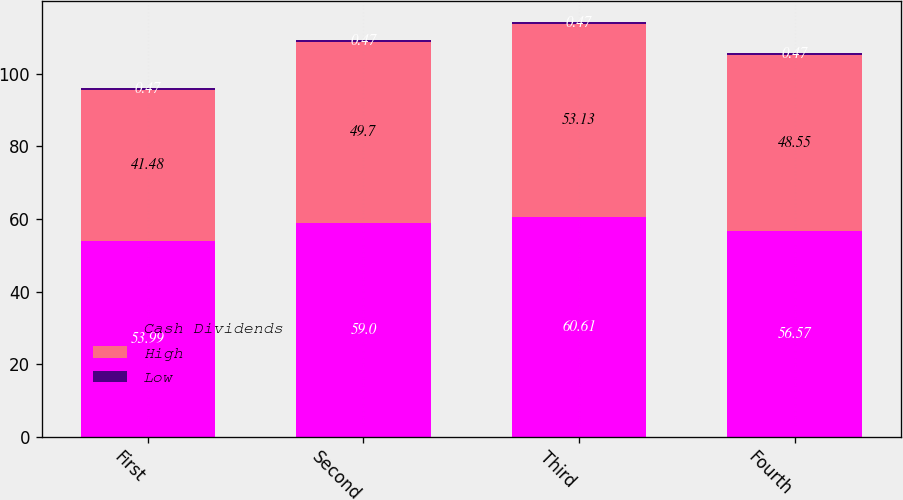<chart> <loc_0><loc_0><loc_500><loc_500><stacked_bar_chart><ecel><fcel>First<fcel>Second<fcel>Third<fcel>Fourth<nl><fcel>Cash Dividends<fcel>53.99<fcel>59<fcel>60.61<fcel>56.57<nl><fcel>High<fcel>41.48<fcel>49.7<fcel>53.13<fcel>48.55<nl><fcel>Low<fcel>0.47<fcel>0.47<fcel>0.47<fcel>0.47<nl></chart> 